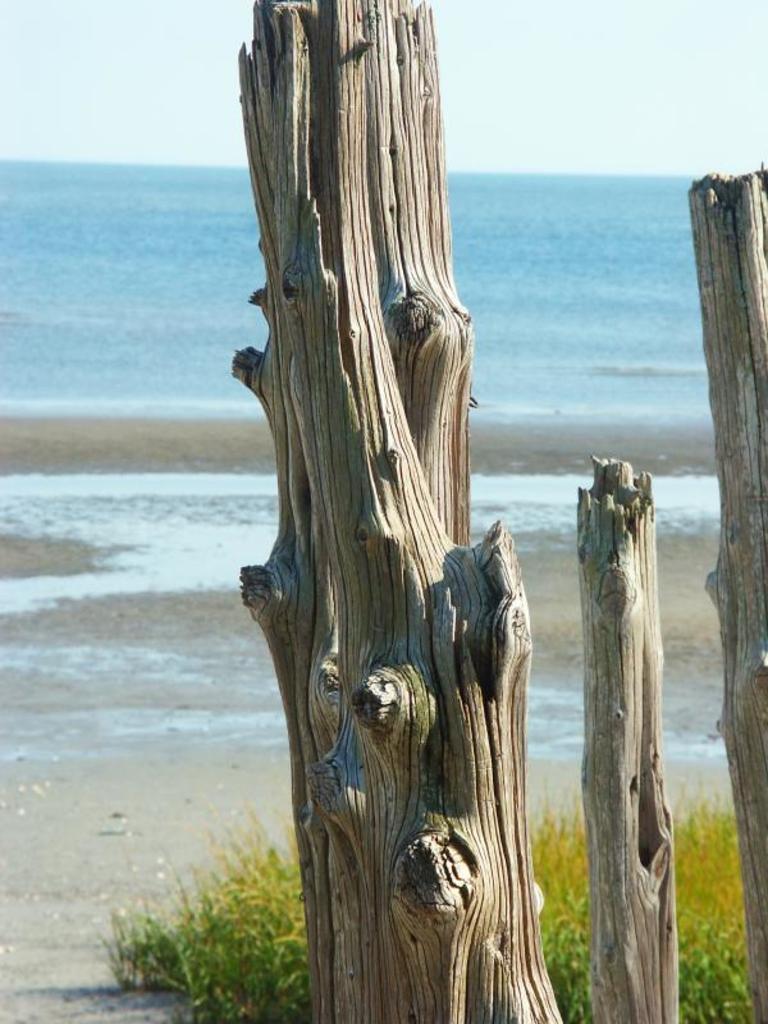Can you describe this image briefly? In this image I can see some trunks. To the side of these I can see the grass, sand and water. In the background I can see the sky. 